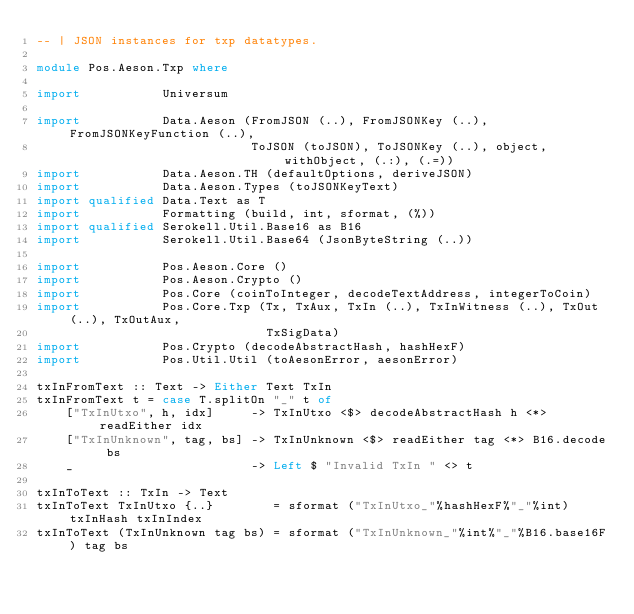Convert code to text. <code><loc_0><loc_0><loc_500><loc_500><_Haskell_>-- | JSON instances for txp datatypes.

module Pos.Aeson.Txp where

import           Universum

import           Data.Aeson (FromJSON (..), FromJSONKey (..), FromJSONKeyFunction (..),
                             ToJSON (toJSON), ToJSONKey (..), object, withObject, (.:), (.=))
import           Data.Aeson.TH (defaultOptions, deriveJSON)
import           Data.Aeson.Types (toJSONKeyText)
import qualified Data.Text as T
import           Formatting (build, int, sformat, (%))
import qualified Serokell.Util.Base16 as B16
import           Serokell.Util.Base64 (JsonByteString (..))

import           Pos.Aeson.Core ()
import           Pos.Aeson.Crypto ()
import           Pos.Core (coinToInteger, decodeTextAddress, integerToCoin)
import           Pos.Core.Txp (Tx, TxAux, TxIn (..), TxInWitness (..), TxOut (..), TxOutAux,
                               TxSigData)
import           Pos.Crypto (decodeAbstractHash, hashHexF)
import           Pos.Util.Util (toAesonError, aesonError)

txInFromText :: Text -> Either Text TxIn
txInFromText t = case T.splitOn "_" t of
    ["TxInUtxo", h, idx]     -> TxInUtxo <$> decodeAbstractHash h <*> readEither idx
    ["TxInUnknown", tag, bs] -> TxInUnknown <$> readEither tag <*> B16.decode bs
    _                        -> Left $ "Invalid TxIn " <> t

txInToText :: TxIn -> Text
txInToText TxInUtxo {..}        = sformat ("TxInUtxo_"%hashHexF%"_"%int) txInHash txInIndex
txInToText (TxInUnknown tag bs) = sformat ("TxInUnknown_"%int%"_"%B16.base16F) tag bs
</code> 